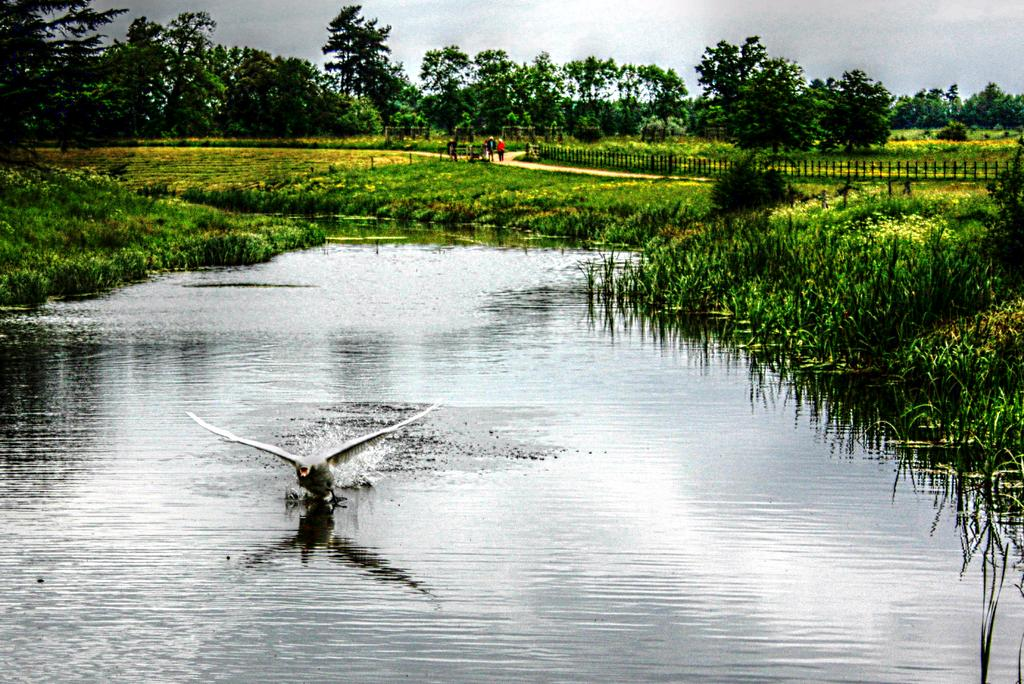What is the primary element visible in the image? There is water in the image. What object can be seen in the water? There is a board in the water. What type of terrain is present in the image? There is grass in the image. What architectural feature is visible in the image? There is a fence in the image. What can be seen in the distance in the image? There are trees in the background of the image, and the sky is visible in the background as well. Are there any living beings present in the image? Yes, there are people in the image. What theory is being discussed by the people in the image? There is no indication in the image that the people are discussing any theories. Can you tell me how many volleyballs are visible in the image? There are no volleyballs present in the image. 